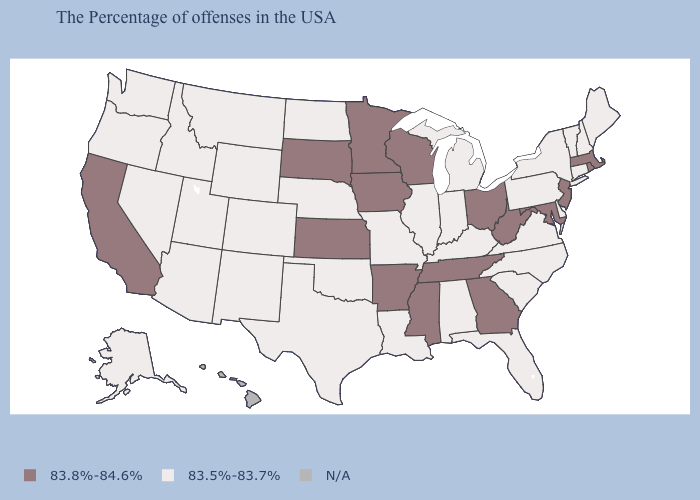Name the states that have a value in the range 83.8%-84.6%?
Be succinct. Massachusetts, Rhode Island, New Jersey, Maryland, West Virginia, Ohio, Georgia, Tennessee, Wisconsin, Mississippi, Arkansas, Minnesota, Iowa, Kansas, South Dakota, California. Does Utah have the lowest value in the West?
Quick response, please. Yes. What is the value of New Jersey?
Keep it brief. 83.8%-84.6%. What is the value of Delaware?
Be succinct. 83.5%-83.7%. What is the value of Ohio?
Quick response, please. 83.8%-84.6%. How many symbols are there in the legend?
Keep it brief. 3. How many symbols are there in the legend?
Give a very brief answer. 3. Does California have the lowest value in the West?
Give a very brief answer. No. Name the states that have a value in the range N/A?
Short answer required. Hawaii. What is the value of New Jersey?
Keep it brief. 83.8%-84.6%. Among the states that border Arkansas , does Tennessee have the highest value?
Be succinct. Yes. How many symbols are there in the legend?
Concise answer only. 3. What is the value of West Virginia?
Keep it brief. 83.8%-84.6%. Which states hav the highest value in the MidWest?
Concise answer only. Ohio, Wisconsin, Minnesota, Iowa, Kansas, South Dakota. Name the states that have a value in the range N/A?
Give a very brief answer. Hawaii. 